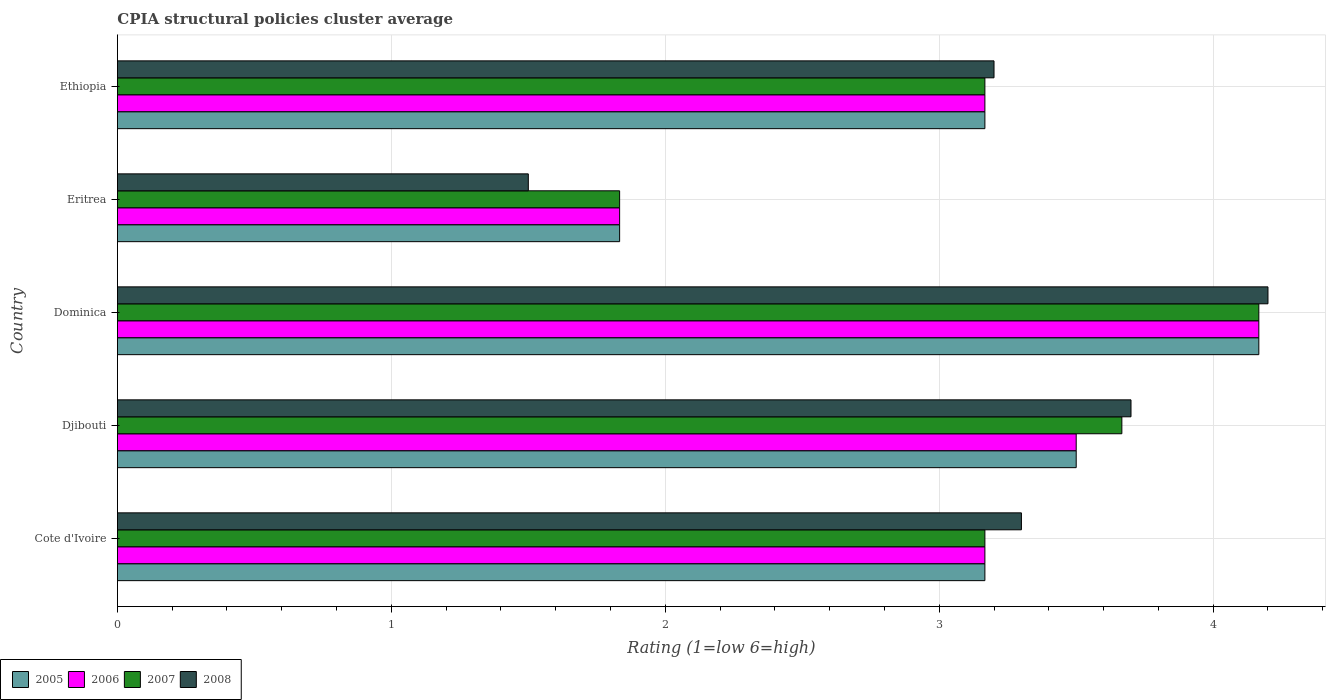How many groups of bars are there?
Make the answer very short. 5. Are the number of bars on each tick of the Y-axis equal?
Your answer should be compact. Yes. How many bars are there on the 5th tick from the bottom?
Provide a succinct answer. 4. What is the label of the 5th group of bars from the top?
Your answer should be compact. Cote d'Ivoire. In how many cases, is the number of bars for a given country not equal to the number of legend labels?
Offer a very short reply. 0. What is the CPIA rating in 2008 in Dominica?
Your response must be concise. 4.2. Across all countries, what is the maximum CPIA rating in 2006?
Your answer should be compact. 4.17. Across all countries, what is the minimum CPIA rating in 2006?
Provide a succinct answer. 1.83. In which country was the CPIA rating in 2005 maximum?
Provide a succinct answer. Dominica. In which country was the CPIA rating in 2006 minimum?
Ensure brevity in your answer.  Eritrea. What is the total CPIA rating in 2007 in the graph?
Give a very brief answer. 16. What is the difference between the CPIA rating in 2008 in Djibouti and that in Ethiopia?
Your response must be concise. 0.5. What is the difference between the CPIA rating in 2005 in Dominica and the CPIA rating in 2008 in Djibouti?
Offer a terse response. 0.47. What is the average CPIA rating in 2007 per country?
Offer a very short reply. 3.2. What is the difference between the CPIA rating in 2008 and CPIA rating in 2006 in Eritrea?
Provide a short and direct response. -0.33. What is the ratio of the CPIA rating in 2005 in Cote d'Ivoire to that in Eritrea?
Offer a very short reply. 1.73. What is the difference between the highest and the second highest CPIA rating in 2008?
Keep it short and to the point. 0.5. What is the difference between the highest and the lowest CPIA rating in 2007?
Make the answer very short. 2.33. Is it the case that in every country, the sum of the CPIA rating in 2005 and CPIA rating in 2007 is greater than the sum of CPIA rating in 2006 and CPIA rating in 2008?
Ensure brevity in your answer.  No. How many bars are there?
Make the answer very short. 20. Are all the bars in the graph horizontal?
Offer a terse response. Yes. What is the difference between two consecutive major ticks on the X-axis?
Ensure brevity in your answer.  1. Are the values on the major ticks of X-axis written in scientific E-notation?
Your response must be concise. No. Does the graph contain any zero values?
Make the answer very short. No. Does the graph contain grids?
Your answer should be very brief. Yes. How many legend labels are there?
Ensure brevity in your answer.  4. How are the legend labels stacked?
Offer a terse response. Horizontal. What is the title of the graph?
Your answer should be very brief. CPIA structural policies cluster average. Does "2010" appear as one of the legend labels in the graph?
Your answer should be compact. No. What is the label or title of the Y-axis?
Provide a succinct answer. Country. What is the Rating (1=low 6=high) in 2005 in Cote d'Ivoire?
Give a very brief answer. 3.17. What is the Rating (1=low 6=high) of 2006 in Cote d'Ivoire?
Your response must be concise. 3.17. What is the Rating (1=low 6=high) in 2007 in Cote d'Ivoire?
Ensure brevity in your answer.  3.17. What is the Rating (1=low 6=high) in 2005 in Djibouti?
Offer a terse response. 3.5. What is the Rating (1=low 6=high) in 2006 in Djibouti?
Give a very brief answer. 3.5. What is the Rating (1=low 6=high) of 2007 in Djibouti?
Ensure brevity in your answer.  3.67. What is the Rating (1=low 6=high) of 2005 in Dominica?
Ensure brevity in your answer.  4.17. What is the Rating (1=low 6=high) of 2006 in Dominica?
Provide a succinct answer. 4.17. What is the Rating (1=low 6=high) in 2007 in Dominica?
Your response must be concise. 4.17. What is the Rating (1=low 6=high) in 2005 in Eritrea?
Offer a very short reply. 1.83. What is the Rating (1=low 6=high) of 2006 in Eritrea?
Keep it short and to the point. 1.83. What is the Rating (1=low 6=high) of 2007 in Eritrea?
Your answer should be very brief. 1.83. What is the Rating (1=low 6=high) of 2005 in Ethiopia?
Offer a very short reply. 3.17. What is the Rating (1=low 6=high) of 2006 in Ethiopia?
Offer a very short reply. 3.17. What is the Rating (1=low 6=high) of 2007 in Ethiopia?
Give a very brief answer. 3.17. What is the Rating (1=low 6=high) in 2008 in Ethiopia?
Your answer should be compact. 3.2. Across all countries, what is the maximum Rating (1=low 6=high) of 2005?
Your answer should be compact. 4.17. Across all countries, what is the maximum Rating (1=low 6=high) of 2006?
Keep it short and to the point. 4.17. Across all countries, what is the maximum Rating (1=low 6=high) in 2007?
Keep it short and to the point. 4.17. Across all countries, what is the maximum Rating (1=low 6=high) in 2008?
Offer a terse response. 4.2. Across all countries, what is the minimum Rating (1=low 6=high) of 2005?
Provide a short and direct response. 1.83. Across all countries, what is the minimum Rating (1=low 6=high) of 2006?
Your response must be concise. 1.83. Across all countries, what is the minimum Rating (1=low 6=high) in 2007?
Your response must be concise. 1.83. Across all countries, what is the minimum Rating (1=low 6=high) of 2008?
Provide a short and direct response. 1.5. What is the total Rating (1=low 6=high) of 2005 in the graph?
Your answer should be compact. 15.83. What is the total Rating (1=low 6=high) of 2006 in the graph?
Provide a succinct answer. 15.83. What is the total Rating (1=low 6=high) of 2007 in the graph?
Give a very brief answer. 16. What is the total Rating (1=low 6=high) of 2008 in the graph?
Keep it short and to the point. 15.9. What is the difference between the Rating (1=low 6=high) of 2005 in Cote d'Ivoire and that in Dominica?
Your answer should be compact. -1. What is the difference between the Rating (1=low 6=high) of 2006 in Cote d'Ivoire and that in Dominica?
Offer a terse response. -1. What is the difference between the Rating (1=low 6=high) of 2007 in Cote d'Ivoire and that in Dominica?
Provide a short and direct response. -1. What is the difference between the Rating (1=low 6=high) of 2005 in Cote d'Ivoire and that in Eritrea?
Ensure brevity in your answer.  1.33. What is the difference between the Rating (1=low 6=high) in 2006 in Cote d'Ivoire and that in Eritrea?
Your answer should be very brief. 1.33. What is the difference between the Rating (1=low 6=high) in 2005 in Cote d'Ivoire and that in Ethiopia?
Your answer should be very brief. 0. What is the difference between the Rating (1=low 6=high) in 2006 in Cote d'Ivoire and that in Ethiopia?
Give a very brief answer. 0. What is the difference between the Rating (1=low 6=high) of 2005 in Djibouti and that in Dominica?
Ensure brevity in your answer.  -0.67. What is the difference between the Rating (1=low 6=high) in 2006 in Djibouti and that in Dominica?
Give a very brief answer. -0.67. What is the difference between the Rating (1=low 6=high) in 2007 in Djibouti and that in Dominica?
Make the answer very short. -0.5. What is the difference between the Rating (1=low 6=high) in 2006 in Djibouti and that in Eritrea?
Make the answer very short. 1.67. What is the difference between the Rating (1=low 6=high) of 2007 in Djibouti and that in Eritrea?
Keep it short and to the point. 1.83. What is the difference between the Rating (1=low 6=high) of 2005 in Djibouti and that in Ethiopia?
Provide a short and direct response. 0.33. What is the difference between the Rating (1=low 6=high) in 2007 in Djibouti and that in Ethiopia?
Give a very brief answer. 0.5. What is the difference between the Rating (1=low 6=high) in 2008 in Djibouti and that in Ethiopia?
Give a very brief answer. 0.5. What is the difference between the Rating (1=low 6=high) of 2005 in Dominica and that in Eritrea?
Offer a very short reply. 2.33. What is the difference between the Rating (1=low 6=high) in 2006 in Dominica and that in Eritrea?
Your response must be concise. 2.33. What is the difference between the Rating (1=low 6=high) of 2007 in Dominica and that in Eritrea?
Provide a succinct answer. 2.33. What is the difference between the Rating (1=low 6=high) in 2008 in Dominica and that in Eritrea?
Make the answer very short. 2.7. What is the difference between the Rating (1=low 6=high) of 2005 in Dominica and that in Ethiopia?
Offer a terse response. 1. What is the difference between the Rating (1=low 6=high) in 2006 in Dominica and that in Ethiopia?
Provide a short and direct response. 1. What is the difference between the Rating (1=low 6=high) of 2005 in Eritrea and that in Ethiopia?
Offer a very short reply. -1.33. What is the difference between the Rating (1=low 6=high) of 2006 in Eritrea and that in Ethiopia?
Your answer should be very brief. -1.33. What is the difference between the Rating (1=low 6=high) of 2007 in Eritrea and that in Ethiopia?
Ensure brevity in your answer.  -1.33. What is the difference between the Rating (1=low 6=high) of 2005 in Cote d'Ivoire and the Rating (1=low 6=high) of 2006 in Djibouti?
Your answer should be compact. -0.33. What is the difference between the Rating (1=low 6=high) in 2005 in Cote d'Ivoire and the Rating (1=low 6=high) in 2008 in Djibouti?
Your answer should be very brief. -0.53. What is the difference between the Rating (1=low 6=high) of 2006 in Cote d'Ivoire and the Rating (1=low 6=high) of 2007 in Djibouti?
Give a very brief answer. -0.5. What is the difference between the Rating (1=low 6=high) in 2006 in Cote d'Ivoire and the Rating (1=low 6=high) in 2008 in Djibouti?
Keep it short and to the point. -0.53. What is the difference between the Rating (1=low 6=high) of 2007 in Cote d'Ivoire and the Rating (1=low 6=high) of 2008 in Djibouti?
Make the answer very short. -0.53. What is the difference between the Rating (1=low 6=high) of 2005 in Cote d'Ivoire and the Rating (1=low 6=high) of 2007 in Dominica?
Your response must be concise. -1. What is the difference between the Rating (1=low 6=high) of 2005 in Cote d'Ivoire and the Rating (1=low 6=high) of 2008 in Dominica?
Make the answer very short. -1.03. What is the difference between the Rating (1=low 6=high) of 2006 in Cote d'Ivoire and the Rating (1=low 6=high) of 2007 in Dominica?
Provide a short and direct response. -1. What is the difference between the Rating (1=low 6=high) of 2006 in Cote d'Ivoire and the Rating (1=low 6=high) of 2008 in Dominica?
Your answer should be very brief. -1.03. What is the difference between the Rating (1=low 6=high) in 2007 in Cote d'Ivoire and the Rating (1=low 6=high) in 2008 in Dominica?
Ensure brevity in your answer.  -1.03. What is the difference between the Rating (1=low 6=high) in 2005 in Cote d'Ivoire and the Rating (1=low 6=high) in 2006 in Eritrea?
Provide a succinct answer. 1.33. What is the difference between the Rating (1=low 6=high) in 2005 in Cote d'Ivoire and the Rating (1=low 6=high) in 2007 in Eritrea?
Offer a very short reply. 1.33. What is the difference between the Rating (1=low 6=high) in 2005 in Cote d'Ivoire and the Rating (1=low 6=high) in 2008 in Eritrea?
Offer a terse response. 1.67. What is the difference between the Rating (1=low 6=high) of 2006 in Cote d'Ivoire and the Rating (1=low 6=high) of 2007 in Eritrea?
Provide a succinct answer. 1.33. What is the difference between the Rating (1=low 6=high) in 2005 in Cote d'Ivoire and the Rating (1=low 6=high) in 2006 in Ethiopia?
Your answer should be compact. 0. What is the difference between the Rating (1=low 6=high) in 2005 in Cote d'Ivoire and the Rating (1=low 6=high) in 2007 in Ethiopia?
Keep it short and to the point. 0. What is the difference between the Rating (1=low 6=high) of 2005 in Cote d'Ivoire and the Rating (1=low 6=high) of 2008 in Ethiopia?
Provide a short and direct response. -0.03. What is the difference between the Rating (1=low 6=high) in 2006 in Cote d'Ivoire and the Rating (1=low 6=high) in 2008 in Ethiopia?
Ensure brevity in your answer.  -0.03. What is the difference between the Rating (1=low 6=high) in 2007 in Cote d'Ivoire and the Rating (1=low 6=high) in 2008 in Ethiopia?
Ensure brevity in your answer.  -0.03. What is the difference between the Rating (1=low 6=high) in 2005 in Djibouti and the Rating (1=low 6=high) in 2007 in Dominica?
Your response must be concise. -0.67. What is the difference between the Rating (1=low 6=high) of 2006 in Djibouti and the Rating (1=low 6=high) of 2007 in Dominica?
Your response must be concise. -0.67. What is the difference between the Rating (1=low 6=high) in 2007 in Djibouti and the Rating (1=low 6=high) in 2008 in Dominica?
Keep it short and to the point. -0.53. What is the difference between the Rating (1=low 6=high) in 2005 in Djibouti and the Rating (1=low 6=high) in 2007 in Eritrea?
Give a very brief answer. 1.67. What is the difference between the Rating (1=low 6=high) in 2005 in Djibouti and the Rating (1=low 6=high) in 2008 in Eritrea?
Offer a very short reply. 2. What is the difference between the Rating (1=low 6=high) of 2006 in Djibouti and the Rating (1=low 6=high) of 2007 in Eritrea?
Keep it short and to the point. 1.67. What is the difference between the Rating (1=low 6=high) in 2007 in Djibouti and the Rating (1=low 6=high) in 2008 in Eritrea?
Keep it short and to the point. 2.17. What is the difference between the Rating (1=low 6=high) of 2007 in Djibouti and the Rating (1=low 6=high) of 2008 in Ethiopia?
Provide a succinct answer. 0.47. What is the difference between the Rating (1=low 6=high) in 2005 in Dominica and the Rating (1=low 6=high) in 2006 in Eritrea?
Ensure brevity in your answer.  2.33. What is the difference between the Rating (1=low 6=high) of 2005 in Dominica and the Rating (1=low 6=high) of 2007 in Eritrea?
Offer a very short reply. 2.33. What is the difference between the Rating (1=low 6=high) of 2005 in Dominica and the Rating (1=low 6=high) of 2008 in Eritrea?
Give a very brief answer. 2.67. What is the difference between the Rating (1=low 6=high) of 2006 in Dominica and the Rating (1=low 6=high) of 2007 in Eritrea?
Offer a terse response. 2.33. What is the difference between the Rating (1=low 6=high) in 2006 in Dominica and the Rating (1=low 6=high) in 2008 in Eritrea?
Make the answer very short. 2.67. What is the difference between the Rating (1=low 6=high) of 2007 in Dominica and the Rating (1=low 6=high) of 2008 in Eritrea?
Your answer should be very brief. 2.67. What is the difference between the Rating (1=low 6=high) of 2005 in Dominica and the Rating (1=low 6=high) of 2006 in Ethiopia?
Offer a terse response. 1. What is the difference between the Rating (1=low 6=high) of 2005 in Dominica and the Rating (1=low 6=high) of 2007 in Ethiopia?
Give a very brief answer. 1. What is the difference between the Rating (1=low 6=high) in 2005 in Dominica and the Rating (1=low 6=high) in 2008 in Ethiopia?
Give a very brief answer. 0.97. What is the difference between the Rating (1=low 6=high) in 2006 in Dominica and the Rating (1=low 6=high) in 2007 in Ethiopia?
Your answer should be very brief. 1. What is the difference between the Rating (1=low 6=high) in 2006 in Dominica and the Rating (1=low 6=high) in 2008 in Ethiopia?
Your answer should be compact. 0.97. What is the difference between the Rating (1=low 6=high) of 2007 in Dominica and the Rating (1=low 6=high) of 2008 in Ethiopia?
Your answer should be compact. 0.97. What is the difference between the Rating (1=low 6=high) in 2005 in Eritrea and the Rating (1=low 6=high) in 2006 in Ethiopia?
Keep it short and to the point. -1.33. What is the difference between the Rating (1=low 6=high) in 2005 in Eritrea and the Rating (1=low 6=high) in 2007 in Ethiopia?
Your answer should be very brief. -1.33. What is the difference between the Rating (1=low 6=high) of 2005 in Eritrea and the Rating (1=low 6=high) of 2008 in Ethiopia?
Your answer should be compact. -1.37. What is the difference between the Rating (1=low 6=high) of 2006 in Eritrea and the Rating (1=low 6=high) of 2007 in Ethiopia?
Make the answer very short. -1.33. What is the difference between the Rating (1=low 6=high) in 2006 in Eritrea and the Rating (1=low 6=high) in 2008 in Ethiopia?
Give a very brief answer. -1.37. What is the difference between the Rating (1=low 6=high) in 2007 in Eritrea and the Rating (1=low 6=high) in 2008 in Ethiopia?
Keep it short and to the point. -1.37. What is the average Rating (1=low 6=high) in 2005 per country?
Offer a terse response. 3.17. What is the average Rating (1=low 6=high) of 2006 per country?
Your answer should be compact. 3.17. What is the average Rating (1=low 6=high) of 2007 per country?
Offer a very short reply. 3.2. What is the average Rating (1=low 6=high) in 2008 per country?
Your answer should be compact. 3.18. What is the difference between the Rating (1=low 6=high) in 2005 and Rating (1=low 6=high) in 2008 in Cote d'Ivoire?
Your answer should be compact. -0.13. What is the difference between the Rating (1=low 6=high) of 2006 and Rating (1=low 6=high) of 2008 in Cote d'Ivoire?
Offer a terse response. -0.13. What is the difference between the Rating (1=low 6=high) in 2007 and Rating (1=low 6=high) in 2008 in Cote d'Ivoire?
Keep it short and to the point. -0.13. What is the difference between the Rating (1=low 6=high) in 2005 and Rating (1=low 6=high) in 2006 in Djibouti?
Give a very brief answer. 0. What is the difference between the Rating (1=low 6=high) of 2005 and Rating (1=low 6=high) of 2007 in Djibouti?
Your answer should be very brief. -0.17. What is the difference between the Rating (1=low 6=high) of 2005 and Rating (1=low 6=high) of 2008 in Djibouti?
Offer a terse response. -0.2. What is the difference between the Rating (1=low 6=high) of 2007 and Rating (1=low 6=high) of 2008 in Djibouti?
Offer a terse response. -0.03. What is the difference between the Rating (1=low 6=high) in 2005 and Rating (1=low 6=high) in 2007 in Dominica?
Provide a succinct answer. 0. What is the difference between the Rating (1=low 6=high) in 2005 and Rating (1=low 6=high) in 2008 in Dominica?
Your answer should be very brief. -0.03. What is the difference between the Rating (1=low 6=high) of 2006 and Rating (1=low 6=high) of 2007 in Dominica?
Make the answer very short. 0. What is the difference between the Rating (1=low 6=high) in 2006 and Rating (1=low 6=high) in 2008 in Dominica?
Provide a short and direct response. -0.03. What is the difference between the Rating (1=low 6=high) of 2007 and Rating (1=low 6=high) of 2008 in Dominica?
Your response must be concise. -0.03. What is the difference between the Rating (1=low 6=high) of 2005 and Rating (1=low 6=high) of 2007 in Eritrea?
Keep it short and to the point. 0. What is the difference between the Rating (1=low 6=high) of 2006 and Rating (1=low 6=high) of 2008 in Eritrea?
Your answer should be very brief. 0.33. What is the difference between the Rating (1=low 6=high) of 2007 and Rating (1=low 6=high) of 2008 in Eritrea?
Provide a short and direct response. 0.33. What is the difference between the Rating (1=low 6=high) in 2005 and Rating (1=low 6=high) in 2006 in Ethiopia?
Offer a terse response. 0. What is the difference between the Rating (1=low 6=high) in 2005 and Rating (1=low 6=high) in 2008 in Ethiopia?
Your answer should be compact. -0.03. What is the difference between the Rating (1=low 6=high) of 2006 and Rating (1=low 6=high) of 2008 in Ethiopia?
Keep it short and to the point. -0.03. What is the difference between the Rating (1=low 6=high) in 2007 and Rating (1=low 6=high) in 2008 in Ethiopia?
Make the answer very short. -0.03. What is the ratio of the Rating (1=low 6=high) in 2005 in Cote d'Ivoire to that in Djibouti?
Provide a short and direct response. 0.9. What is the ratio of the Rating (1=low 6=high) in 2006 in Cote d'Ivoire to that in Djibouti?
Provide a succinct answer. 0.9. What is the ratio of the Rating (1=low 6=high) in 2007 in Cote d'Ivoire to that in Djibouti?
Offer a terse response. 0.86. What is the ratio of the Rating (1=low 6=high) of 2008 in Cote d'Ivoire to that in Djibouti?
Your response must be concise. 0.89. What is the ratio of the Rating (1=low 6=high) in 2005 in Cote d'Ivoire to that in Dominica?
Your answer should be compact. 0.76. What is the ratio of the Rating (1=low 6=high) in 2006 in Cote d'Ivoire to that in Dominica?
Your response must be concise. 0.76. What is the ratio of the Rating (1=low 6=high) in 2007 in Cote d'Ivoire to that in Dominica?
Your response must be concise. 0.76. What is the ratio of the Rating (1=low 6=high) of 2008 in Cote d'Ivoire to that in Dominica?
Your response must be concise. 0.79. What is the ratio of the Rating (1=low 6=high) of 2005 in Cote d'Ivoire to that in Eritrea?
Give a very brief answer. 1.73. What is the ratio of the Rating (1=low 6=high) of 2006 in Cote d'Ivoire to that in Eritrea?
Offer a very short reply. 1.73. What is the ratio of the Rating (1=low 6=high) of 2007 in Cote d'Ivoire to that in Eritrea?
Your answer should be compact. 1.73. What is the ratio of the Rating (1=low 6=high) in 2006 in Cote d'Ivoire to that in Ethiopia?
Your answer should be very brief. 1. What is the ratio of the Rating (1=low 6=high) in 2007 in Cote d'Ivoire to that in Ethiopia?
Make the answer very short. 1. What is the ratio of the Rating (1=low 6=high) in 2008 in Cote d'Ivoire to that in Ethiopia?
Provide a short and direct response. 1.03. What is the ratio of the Rating (1=low 6=high) in 2005 in Djibouti to that in Dominica?
Your answer should be compact. 0.84. What is the ratio of the Rating (1=low 6=high) in 2006 in Djibouti to that in Dominica?
Your response must be concise. 0.84. What is the ratio of the Rating (1=low 6=high) of 2008 in Djibouti to that in Dominica?
Keep it short and to the point. 0.88. What is the ratio of the Rating (1=low 6=high) in 2005 in Djibouti to that in Eritrea?
Ensure brevity in your answer.  1.91. What is the ratio of the Rating (1=low 6=high) in 2006 in Djibouti to that in Eritrea?
Your answer should be compact. 1.91. What is the ratio of the Rating (1=low 6=high) in 2007 in Djibouti to that in Eritrea?
Offer a very short reply. 2. What is the ratio of the Rating (1=low 6=high) in 2008 in Djibouti to that in Eritrea?
Offer a very short reply. 2.47. What is the ratio of the Rating (1=low 6=high) in 2005 in Djibouti to that in Ethiopia?
Provide a succinct answer. 1.11. What is the ratio of the Rating (1=low 6=high) in 2006 in Djibouti to that in Ethiopia?
Offer a terse response. 1.11. What is the ratio of the Rating (1=low 6=high) of 2007 in Djibouti to that in Ethiopia?
Keep it short and to the point. 1.16. What is the ratio of the Rating (1=low 6=high) of 2008 in Djibouti to that in Ethiopia?
Your response must be concise. 1.16. What is the ratio of the Rating (1=low 6=high) of 2005 in Dominica to that in Eritrea?
Keep it short and to the point. 2.27. What is the ratio of the Rating (1=low 6=high) of 2006 in Dominica to that in Eritrea?
Keep it short and to the point. 2.27. What is the ratio of the Rating (1=low 6=high) in 2007 in Dominica to that in Eritrea?
Your answer should be compact. 2.27. What is the ratio of the Rating (1=low 6=high) of 2008 in Dominica to that in Eritrea?
Your response must be concise. 2.8. What is the ratio of the Rating (1=low 6=high) in 2005 in Dominica to that in Ethiopia?
Keep it short and to the point. 1.32. What is the ratio of the Rating (1=low 6=high) of 2006 in Dominica to that in Ethiopia?
Offer a very short reply. 1.32. What is the ratio of the Rating (1=low 6=high) in 2007 in Dominica to that in Ethiopia?
Offer a terse response. 1.32. What is the ratio of the Rating (1=low 6=high) in 2008 in Dominica to that in Ethiopia?
Provide a succinct answer. 1.31. What is the ratio of the Rating (1=low 6=high) of 2005 in Eritrea to that in Ethiopia?
Ensure brevity in your answer.  0.58. What is the ratio of the Rating (1=low 6=high) of 2006 in Eritrea to that in Ethiopia?
Provide a short and direct response. 0.58. What is the ratio of the Rating (1=low 6=high) of 2007 in Eritrea to that in Ethiopia?
Offer a very short reply. 0.58. What is the ratio of the Rating (1=low 6=high) of 2008 in Eritrea to that in Ethiopia?
Provide a short and direct response. 0.47. What is the difference between the highest and the second highest Rating (1=low 6=high) in 2006?
Offer a terse response. 0.67. What is the difference between the highest and the lowest Rating (1=low 6=high) of 2005?
Offer a very short reply. 2.33. What is the difference between the highest and the lowest Rating (1=low 6=high) in 2006?
Offer a terse response. 2.33. What is the difference between the highest and the lowest Rating (1=low 6=high) in 2007?
Provide a short and direct response. 2.33. What is the difference between the highest and the lowest Rating (1=low 6=high) in 2008?
Make the answer very short. 2.7. 